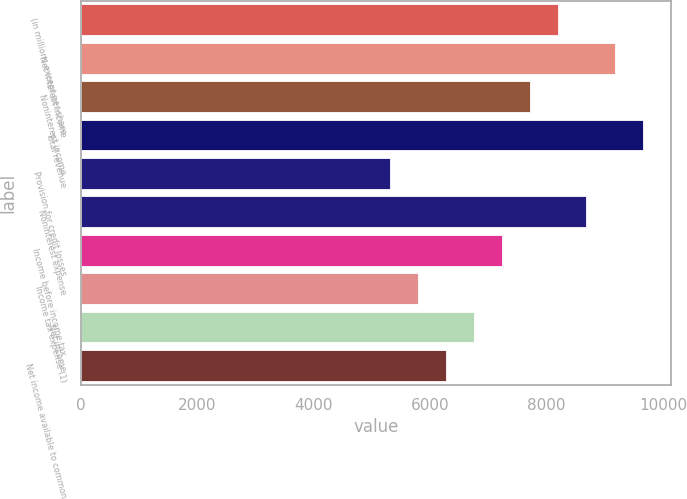Convert chart to OTSL. <chart><loc_0><loc_0><loc_500><loc_500><bar_chart><fcel>(in millions except per-share<fcel>Net interest income<fcel>Noninterest income<fcel>Total revenue<fcel>Provision for credit losses<fcel>Noninterest expense<fcel>Income before income tax<fcel>Income tax expense (1)<fcel>Net income<fcel>Net income available to common<nl><fcel>8200.52<fcel>9165.24<fcel>7718.16<fcel>9647.6<fcel>5306.36<fcel>8682.88<fcel>7235.8<fcel>5788.72<fcel>6753.44<fcel>6271.08<nl></chart> 